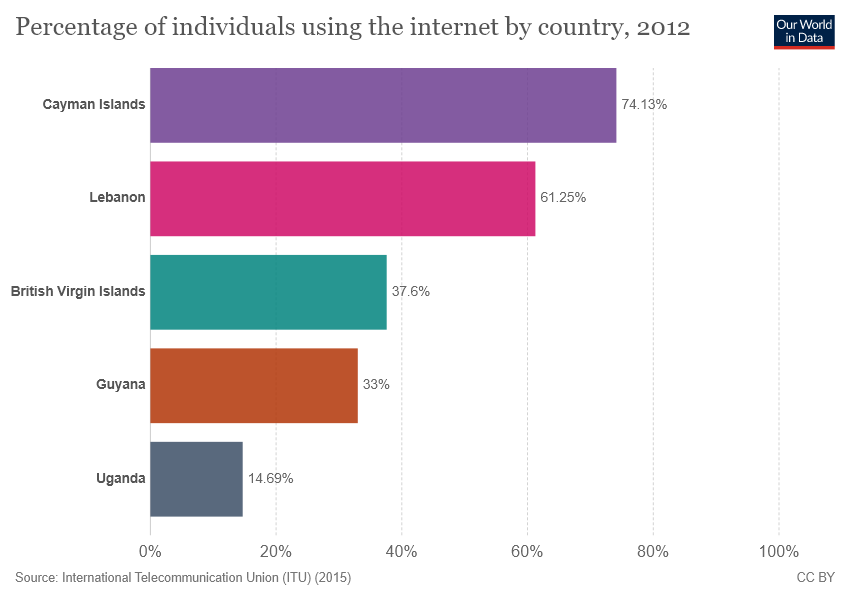List a handful of essential elements in this visual. The Cayman Islands represent 74.13% of a certain country. The sum of the lowest two bars in the graph is greater than the green bar. 